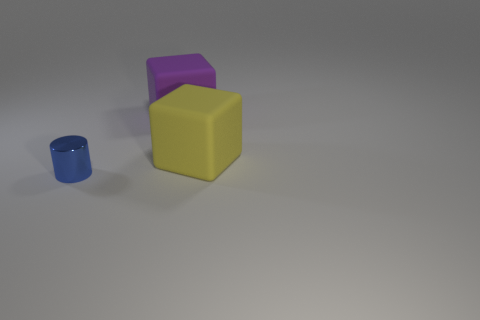Add 2 big purple blocks. How many objects exist? 5 Subtract all cylinders. How many objects are left? 2 Add 3 purple metal cubes. How many purple metal cubes exist? 3 Subtract 0 yellow balls. How many objects are left? 3 Subtract all yellow metallic cylinders. Subtract all small metal cylinders. How many objects are left? 2 Add 1 big matte blocks. How many big matte blocks are left? 3 